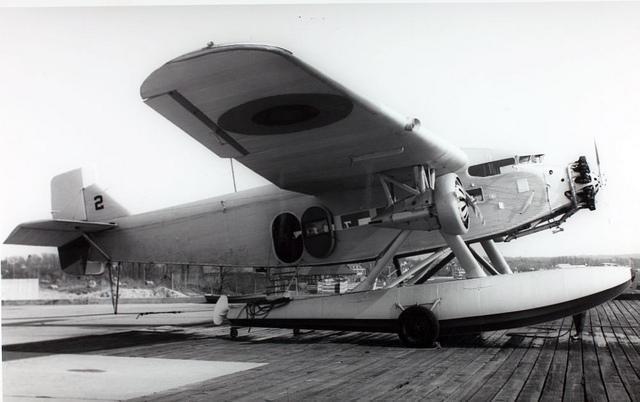How many airplanes can you see?
Give a very brief answer. 2. 